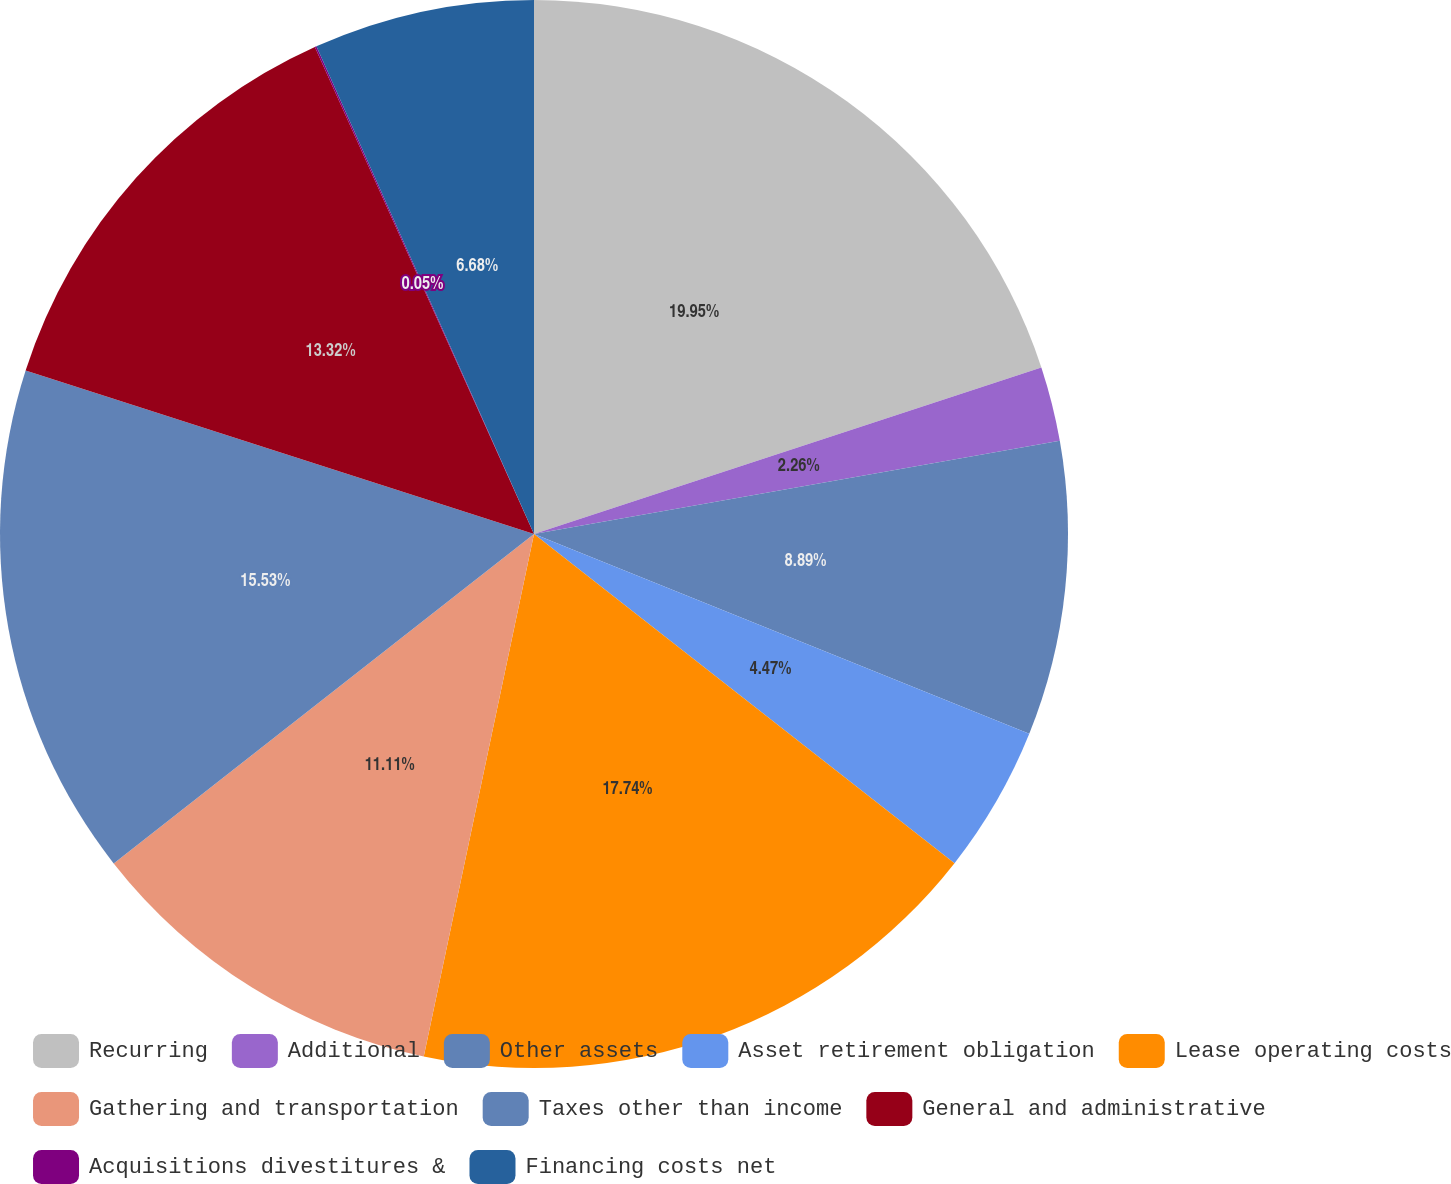Convert chart. <chart><loc_0><loc_0><loc_500><loc_500><pie_chart><fcel>Recurring<fcel>Additional<fcel>Other assets<fcel>Asset retirement obligation<fcel>Lease operating costs<fcel>Gathering and transportation<fcel>Taxes other than income<fcel>General and administrative<fcel>Acquisitions divestitures &<fcel>Financing costs net<nl><fcel>19.95%<fcel>2.26%<fcel>8.89%<fcel>4.47%<fcel>17.74%<fcel>11.11%<fcel>15.53%<fcel>13.32%<fcel>0.05%<fcel>6.68%<nl></chart> 